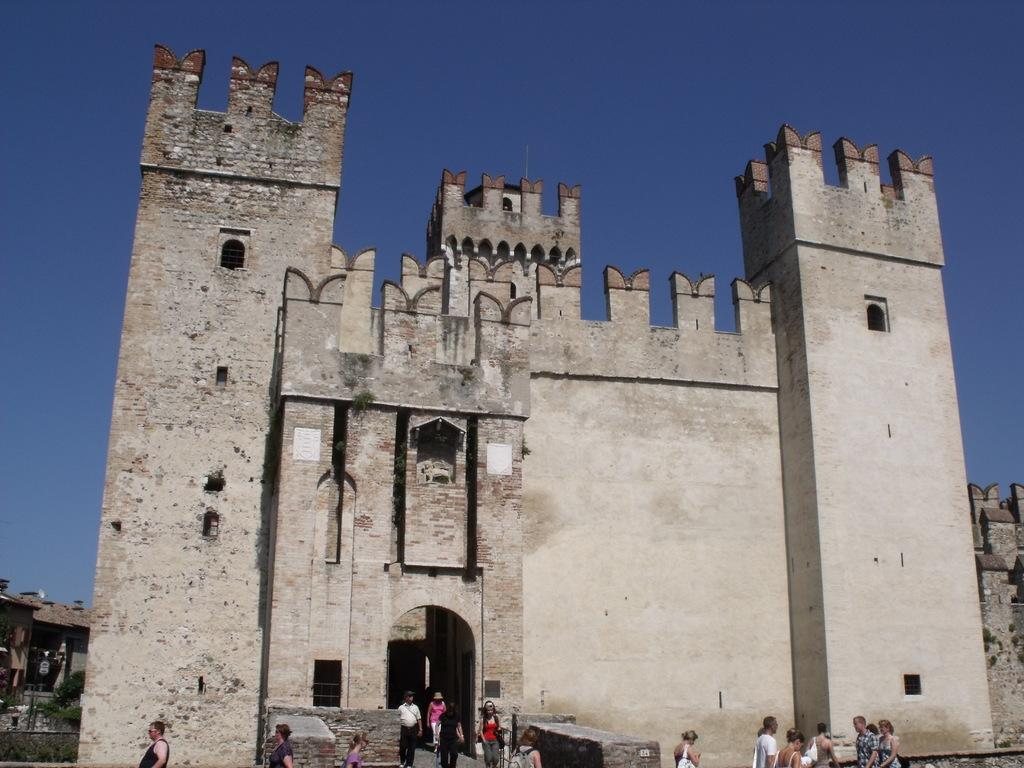What type of structures can be seen in the image? There are buildings in the image. What can be seen in the background of the image? The sky is visible in the background of the image. Who or what is present in the image? There are people in the image. What type of vegetation is present in the image? Plants are present in the image. What type of cork can be seen in the image? There is no cork present in the image. How many shades of green can be seen in the plants in the image? The provided facts do not specify the number of shades of green in the plants, nor do they mention any specific colors. 